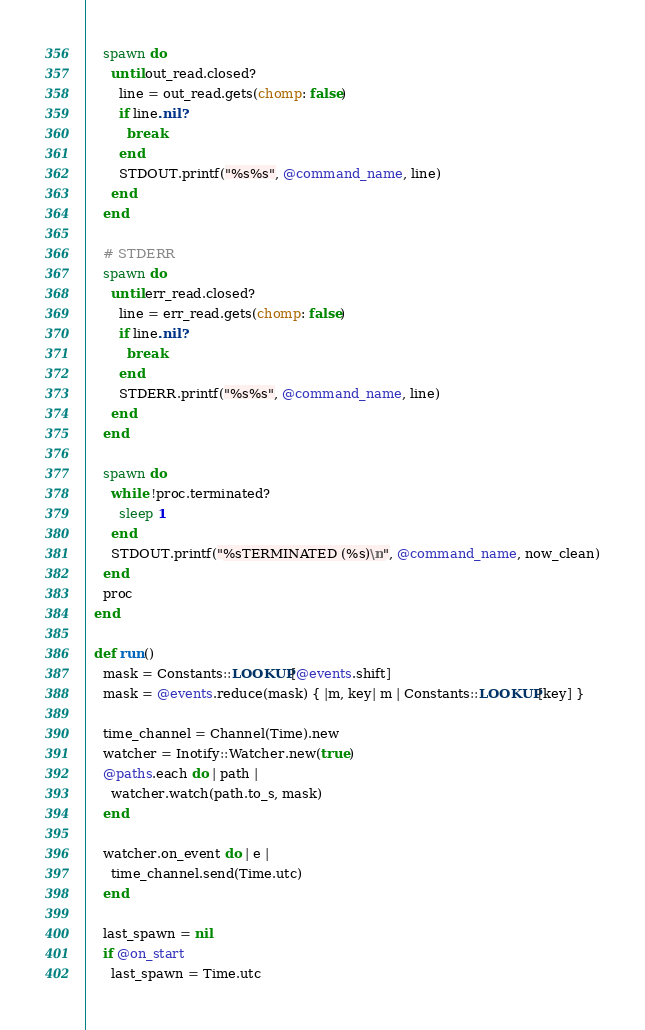Convert code to text. <code><loc_0><loc_0><loc_500><loc_500><_Crystal_>
    spawn do
      until out_read.closed?
        line = out_read.gets(chomp: false)
        if line.nil?
          break
        end
        STDOUT.printf("%s%s", @command_name, line)
      end
    end

    # STDERR
    spawn do
      until err_read.closed?
        line = err_read.gets(chomp: false)
        if line.nil? 
          break
        end
        STDERR.printf("%s%s", @command_name, line)
      end
    end

    spawn do
      while !proc.terminated?
        sleep 1
      end
      STDOUT.printf("%sTERMINATED (%s)\n", @command_name, now_clean)
    end
    proc
  end

  def run()
    mask = Constants::LOOKUP[@events.shift]
    mask = @events.reduce(mask) { |m, key| m | Constants::LOOKUP[key] } 

    time_channel = Channel(Time).new
    watcher = Inotify::Watcher.new(true)
    @paths.each do | path |
      watcher.watch(path.to_s, mask)
    end 

    watcher.on_event do | e |
      time_channel.send(Time.utc)
    end
    
    last_spawn = nil
    if @on_start
      last_spawn = Time.utc</code> 